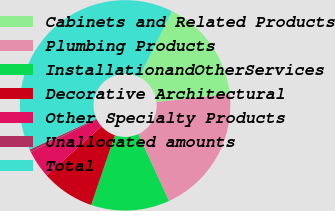Convert chart. <chart><loc_0><loc_0><loc_500><loc_500><pie_chart><fcel>Cabinets and Related Products<fcel>Plumbing Products<fcel>InstallationandOtherServices<fcel>Decorative Architectural<fcel>Other Specialty Products<fcel>Unallocated amounts<fcel>Total<nl><fcel>15.95%<fcel>19.84%<fcel>12.07%<fcel>8.18%<fcel>4.29%<fcel>0.41%<fcel>39.27%<nl></chart> 